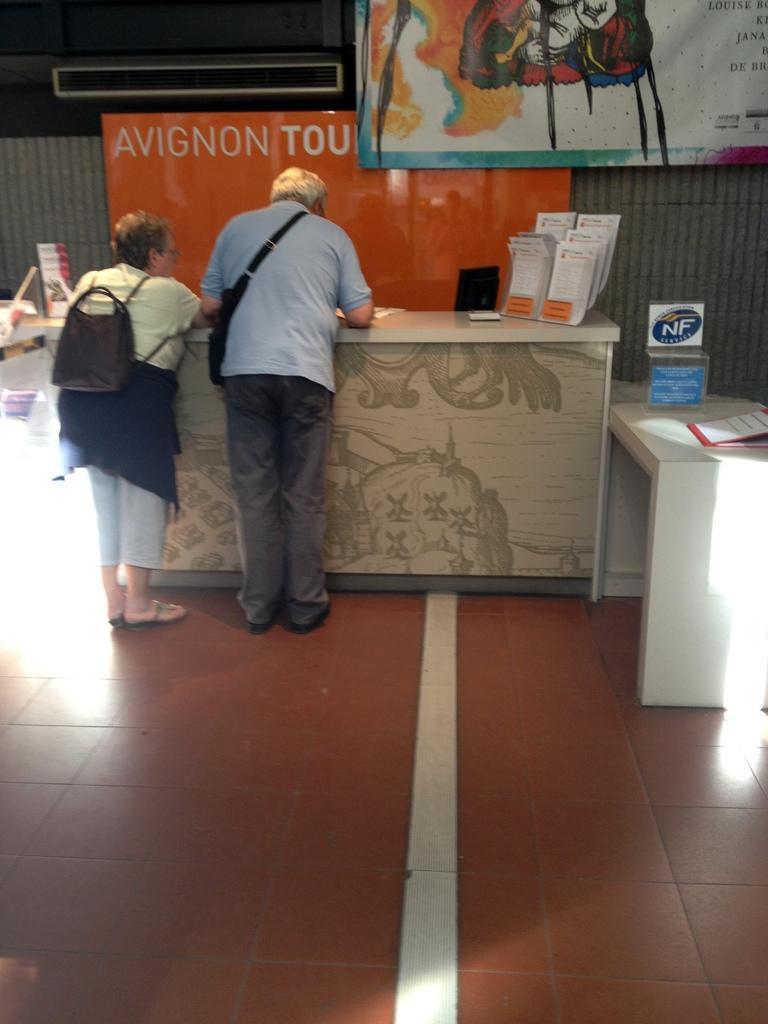How would you summarize this image in a sentence or two? In this image I can see a woman and a man are standing facing towards back side. In front of them there is a table on which few papers are placed. On the right side there is another small table on which a glass object and few papers are placed. On the left side there are few objects on the floor. In the background there are two banners on which I can see the text and some paintings and also there is a screen. 